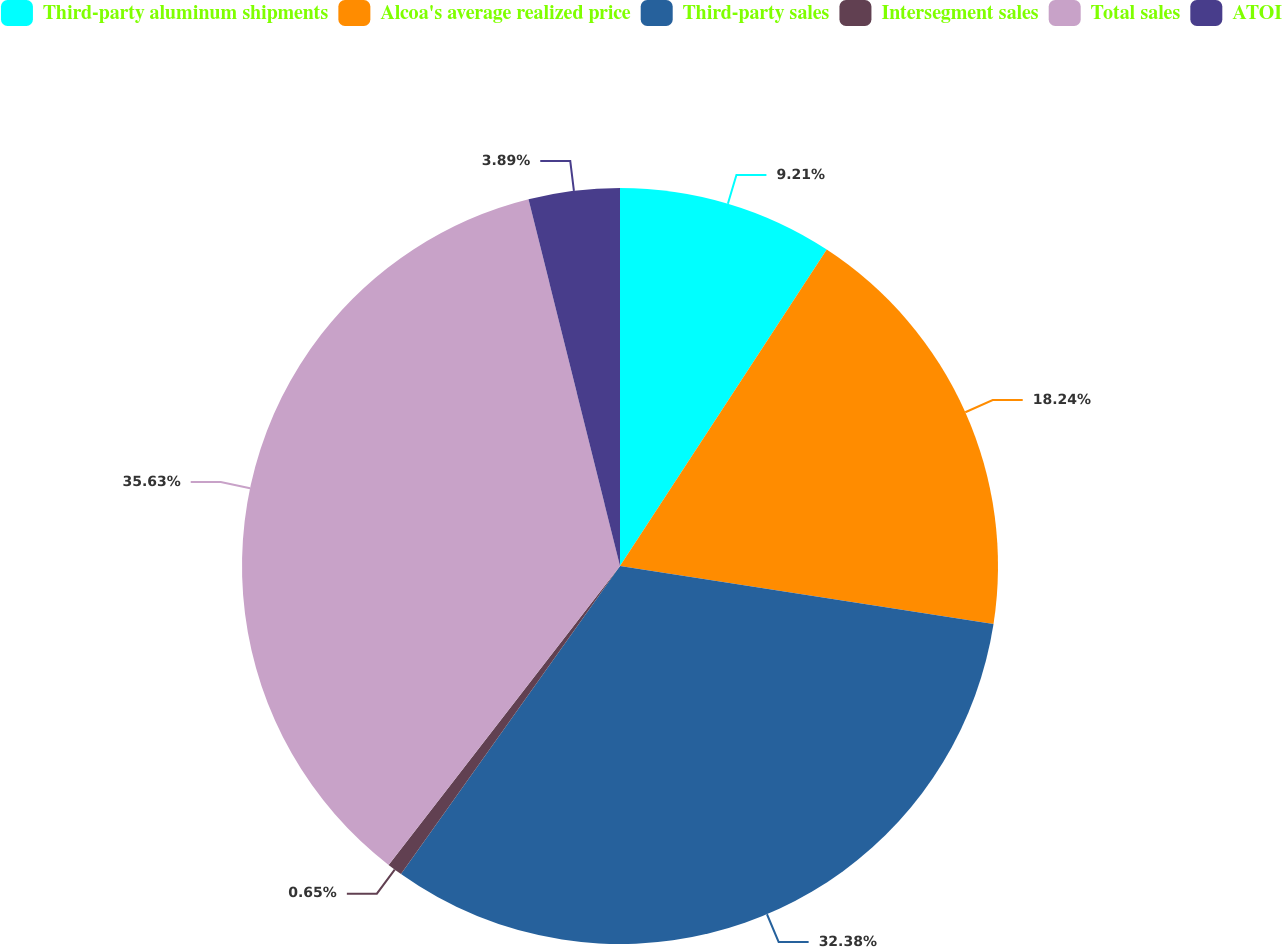Convert chart to OTSL. <chart><loc_0><loc_0><loc_500><loc_500><pie_chart><fcel>Third-party aluminum shipments<fcel>Alcoa's average realized price<fcel>Third-party sales<fcel>Intersegment sales<fcel>Total sales<fcel>ATOI<nl><fcel>9.21%<fcel>18.24%<fcel>32.38%<fcel>0.65%<fcel>35.62%<fcel>3.89%<nl></chart> 